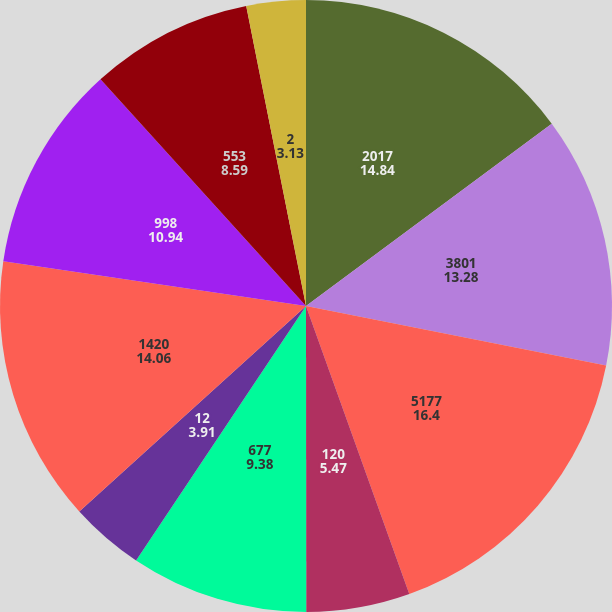Convert chart to OTSL. <chart><loc_0><loc_0><loc_500><loc_500><pie_chart><fcel>2017<fcel>3801<fcel>5177<fcel>120<fcel>677<fcel>12<fcel>1420<fcel>998<fcel>553<fcel>2<nl><fcel>14.84%<fcel>13.28%<fcel>16.4%<fcel>5.47%<fcel>9.38%<fcel>3.91%<fcel>14.06%<fcel>10.94%<fcel>8.59%<fcel>3.13%<nl></chart> 